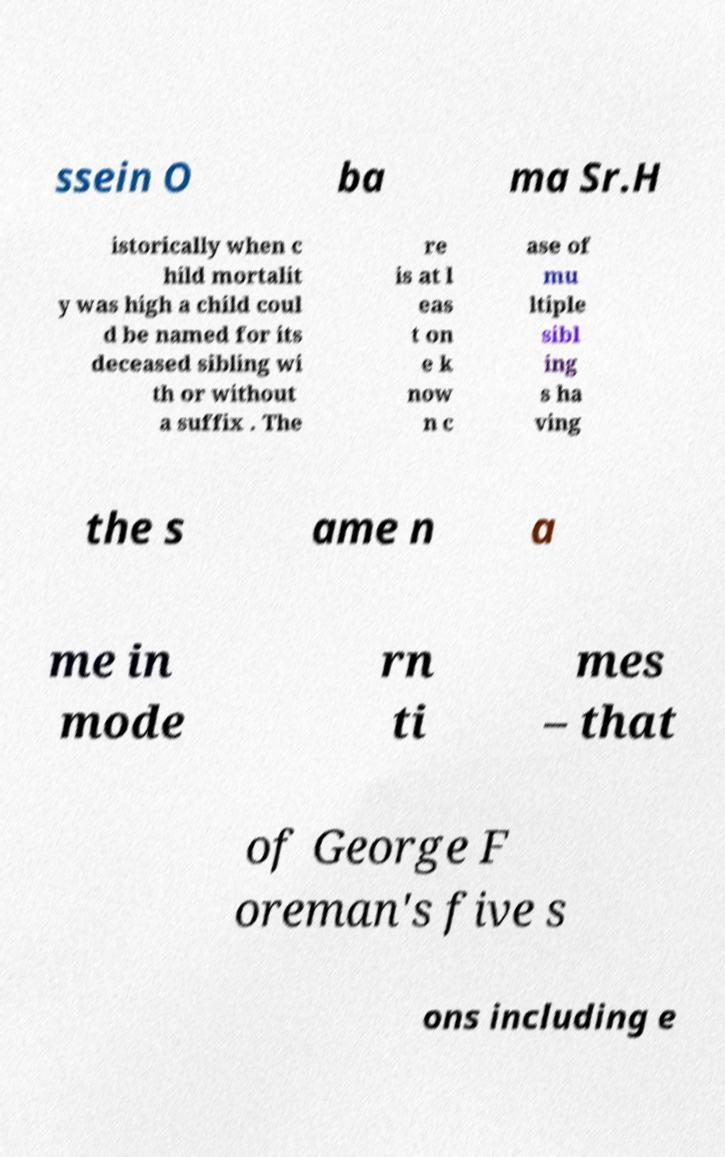There's text embedded in this image that I need extracted. Can you transcribe it verbatim? ssein O ba ma Sr.H istorically when c hild mortalit y was high a child coul d be named for its deceased sibling wi th or without a suffix . The re is at l eas t on e k now n c ase of mu ltiple sibl ing s ha ving the s ame n a me in mode rn ti mes – that of George F oreman's five s ons including e 